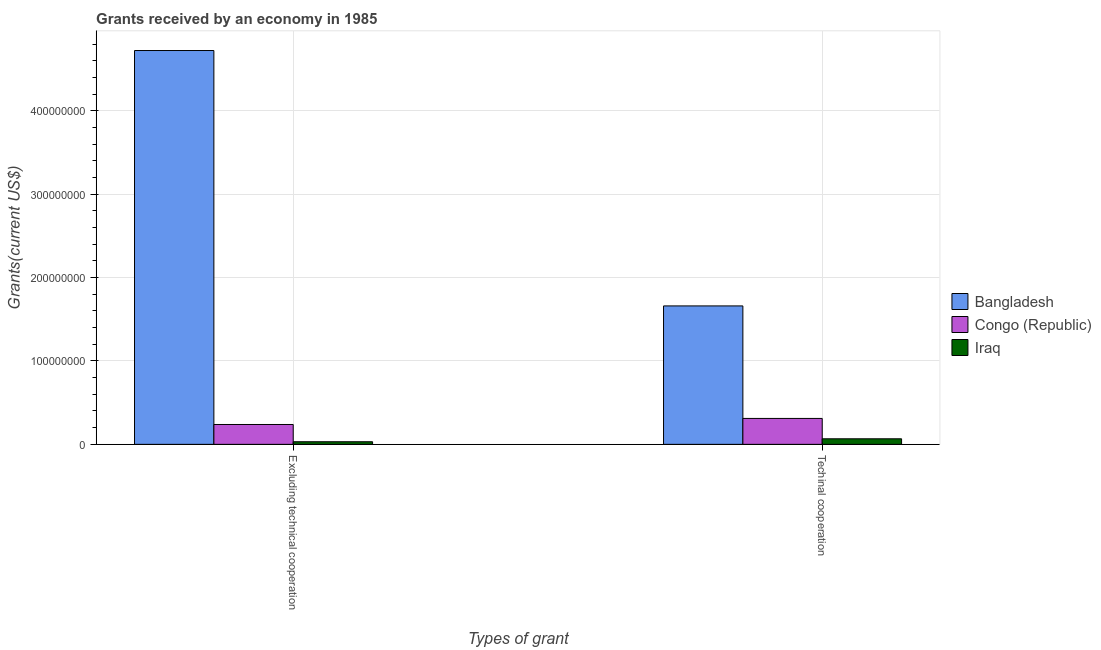How many bars are there on the 2nd tick from the left?
Ensure brevity in your answer.  3. How many bars are there on the 1st tick from the right?
Your answer should be very brief. 3. What is the label of the 1st group of bars from the left?
Give a very brief answer. Excluding technical cooperation. What is the amount of grants received(excluding technical cooperation) in Iraq?
Ensure brevity in your answer.  3.13e+06. Across all countries, what is the maximum amount of grants received(excluding technical cooperation)?
Provide a succinct answer. 4.72e+08. Across all countries, what is the minimum amount of grants received(excluding technical cooperation)?
Give a very brief answer. 3.13e+06. In which country was the amount of grants received(including technical cooperation) maximum?
Provide a short and direct response. Bangladesh. In which country was the amount of grants received(including technical cooperation) minimum?
Ensure brevity in your answer.  Iraq. What is the total amount of grants received(including technical cooperation) in the graph?
Make the answer very short. 2.04e+08. What is the difference between the amount of grants received(including technical cooperation) in Iraq and that in Bangladesh?
Keep it short and to the point. -1.59e+08. What is the difference between the amount of grants received(excluding technical cooperation) in Bangladesh and the amount of grants received(including technical cooperation) in Congo (Republic)?
Your answer should be very brief. 4.41e+08. What is the average amount of grants received(including technical cooperation) per country?
Your response must be concise. 6.79e+07. What is the difference between the amount of grants received(excluding technical cooperation) and amount of grants received(including technical cooperation) in Iraq?
Give a very brief answer. -3.54e+06. In how many countries, is the amount of grants received(excluding technical cooperation) greater than 360000000 US$?
Your response must be concise. 1. What is the ratio of the amount of grants received(including technical cooperation) in Congo (Republic) to that in Iraq?
Your answer should be compact. 4.66. Is the amount of grants received(including technical cooperation) in Bangladesh less than that in Congo (Republic)?
Your answer should be very brief. No. In how many countries, is the amount of grants received(excluding technical cooperation) greater than the average amount of grants received(excluding technical cooperation) taken over all countries?
Keep it short and to the point. 1. What does the 1st bar from the left in Excluding technical cooperation represents?
Your response must be concise. Bangladesh. What does the 1st bar from the right in Techinal cooperation represents?
Provide a short and direct response. Iraq. How many bars are there?
Your answer should be compact. 6. How many countries are there in the graph?
Make the answer very short. 3. What is the difference between two consecutive major ticks on the Y-axis?
Your response must be concise. 1.00e+08. Are the values on the major ticks of Y-axis written in scientific E-notation?
Offer a very short reply. No. Does the graph contain grids?
Offer a terse response. Yes. Where does the legend appear in the graph?
Provide a succinct answer. Center right. How are the legend labels stacked?
Your response must be concise. Vertical. What is the title of the graph?
Offer a terse response. Grants received by an economy in 1985. What is the label or title of the X-axis?
Give a very brief answer. Types of grant. What is the label or title of the Y-axis?
Your answer should be compact. Grants(current US$). What is the Grants(current US$) in Bangladesh in Excluding technical cooperation?
Keep it short and to the point. 4.72e+08. What is the Grants(current US$) of Congo (Republic) in Excluding technical cooperation?
Give a very brief answer. 2.38e+07. What is the Grants(current US$) in Iraq in Excluding technical cooperation?
Your answer should be very brief. 3.13e+06. What is the Grants(current US$) in Bangladesh in Techinal cooperation?
Offer a terse response. 1.66e+08. What is the Grants(current US$) of Congo (Republic) in Techinal cooperation?
Keep it short and to the point. 3.11e+07. What is the Grants(current US$) of Iraq in Techinal cooperation?
Make the answer very short. 6.67e+06. Across all Types of grant, what is the maximum Grants(current US$) of Bangladesh?
Provide a short and direct response. 4.72e+08. Across all Types of grant, what is the maximum Grants(current US$) in Congo (Republic)?
Your answer should be very brief. 3.11e+07. Across all Types of grant, what is the maximum Grants(current US$) of Iraq?
Make the answer very short. 6.67e+06. Across all Types of grant, what is the minimum Grants(current US$) of Bangladesh?
Offer a very short reply. 1.66e+08. Across all Types of grant, what is the minimum Grants(current US$) in Congo (Republic)?
Give a very brief answer. 2.38e+07. Across all Types of grant, what is the minimum Grants(current US$) of Iraq?
Provide a short and direct response. 3.13e+06. What is the total Grants(current US$) of Bangladesh in the graph?
Keep it short and to the point. 6.38e+08. What is the total Grants(current US$) of Congo (Republic) in the graph?
Your answer should be very brief. 5.49e+07. What is the total Grants(current US$) of Iraq in the graph?
Keep it short and to the point. 9.80e+06. What is the difference between the Grants(current US$) in Bangladesh in Excluding technical cooperation and that in Techinal cooperation?
Give a very brief answer. 3.06e+08. What is the difference between the Grants(current US$) in Congo (Republic) in Excluding technical cooperation and that in Techinal cooperation?
Provide a succinct answer. -7.27e+06. What is the difference between the Grants(current US$) of Iraq in Excluding technical cooperation and that in Techinal cooperation?
Keep it short and to the point. -3.54e+06. What is the difference between the Grants(current US$) in Bangladesh in Excluding technical cooperation and the Grants(current US$) in Congo (Republic) in Techinal cooperation?
Ensure brevity in your answer.  4.41e+08. What is the difference between the Grants(current US$) in Bangladesh in Excluding technical cooperation and the Grants(current US$) in Iraq in Techinal cooperation?
Provide a short and direct response. 4.66e+08. What is the difference between the Grants(current US$) in Congo (Republic) in Excluding technical cooperation and the Grants(current US$) in Iraq in Techinal cooperation?
Keep it short and to the point. 1.72e+07. What is the average Grants(current US$) of Bangladesh per Types of grant?
Ensure brevity in your answer.  3.19e+08. What is the average Grants(current US$) of Congo (Republic) per Types of grant?
Your answer should be very brief. 2.75e+07. What is the average Grants(current US$) in Iraq per Types of grant?
Your response must be concise. 4.90e+06. What is the difference between the Grants(current US$) in Bangladesh and Grants(current US$) in Congo (Republic) in Excluding technical cooperation?
Your answer should be compact. 4.48e+08. What is the difference between the Grants(current US$) of Bangladesh and Grants(current US$) of Iraq in Excluding technical cooperation?
Your answer should be very brief. 4.69e+08. What is the difference between the Grants(current US$) of Congo (Republic) and Grants(current US$) of Iraq in Excluding technical cooperation?
Give a very brief answer. 2.07e+07. What is the difference between the Grants(current US$) in Bangladesh and Grants(current US$) in Congo (Republic) in Techinal cooperation?
Provide a succinct answer. 1.35e+08. What is the difference between the Grants(current US$) in Bangladesh and Grants(current US$) in Iraq in Techinal cooperation?
Offer a terse response. 1.59e+08. What is the difference between the Grants(current US$) in Congo (Republic) and Grants(current US$) in Iraq in Techinal cooperation?
Ensure brevity in your answer.  2.44e+07. What is the ratio of the Grants(current US$) of Bangladesh in Excluding technical cooperation to that in Techinal cooperation?
Offer a terse response. 2.84. What is the ratio of the Grants(current US$) in Congo (Republic) in Excluding technical cooperation to that in Techinal cooperation?
Your answer should be compact. 0.77. What is the ratio of the Grants(current US$) of Iraq in Excluding technical cooperation to that in Techinal cooperation?
Ensure brevity in your answer.  0.47. What is the difference between the highest and the second highest Grants(current US$) of Bangladesh?
Your answer should be very brief. 3.06e+08. What is the difference between the highest and the second highest Grants(current US$) in Congo (Republic)?
Keep it short and to the point. 7.27e+06. What is the difference between the highest and the second highest Grants(current US$) in Iraq?
Offer a terse response. 3.54e+06. What is the difference between the highest and the lowest Grants(current US$) in Bangladesh?
Make the answer very short. 3.06e+08. What is the difference between the highest and the lowest Grants(current US$) of Congo (Republic)?
Your response must be concise. 7.27e+06. What is the difference between the highest and the lowest Grants(current US$) in Iraq?
Provide a short and direct response. 3.54e+06. 